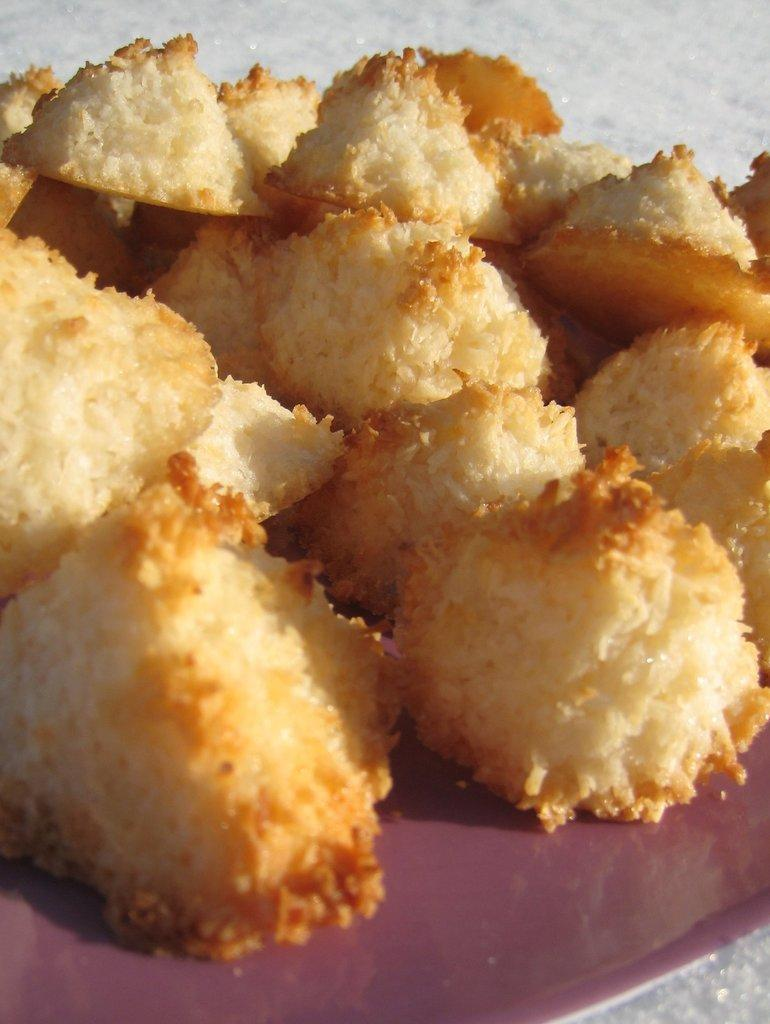What is the main subject of the image? There is a food item on a plate in the image. Where is the food item located on the plate? The food item is in the center of the image. What type of animals can be seen at the zoo in the image? There is no zoo present in the image; it features a food item on a plate. What does the porter carry in the image? There is no porter present in the image; it features a food item on a plate. 